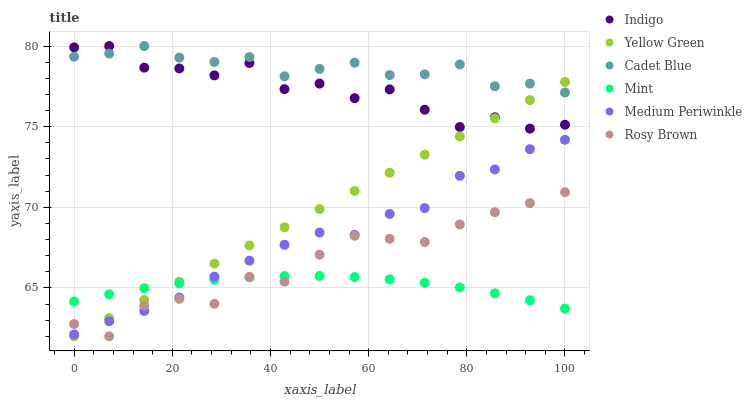Does Mint have the minimum area under the curve?
Answer yes or no. Yes. Does Cadet Blue have the maximum area under the curve?
Answer yes or no. Yes. Does Indigo have the minimum area under the curve?
Answer yes or no. No. Does Indigo have the maximum area under the curve?
Answer yes or no. No. Is Yellow Green the smoothest?
Answer yes or no. Yes. Is Indigo the roughest?
Answer yes or no. Yes. Is Indigo the smoothest?
Answer yes or no. No. Is Yellow Green the roughest?
Answer yes or no. No. Does Yellow Green have the lowest value?
Answer yes or no. Yes. Does Indigo have the lowest value?
Answer yes or no. No. Does Indigo have the highest value?
Answer yes or no. Yes. Does Yellow Green have the highest value?
Answer yes or no. No. Is Rosy Brown less than Cadet Blue?
Answer yes or no. Yes. Is Indigo greater than Medium Periwinkle?
Answer yes or no. Yes. Does Yellow Green intersect Rosy Brown?
Answer yes or no. Yes. Is Yellow Green less than Rosy Brown?
Answer yes or no. No. Is Yellow Green greater than Rosy Brown?
Answer yes or no. No. Does Rosy Brown intersect Cadet Blue?
Answer yes or no. No. 